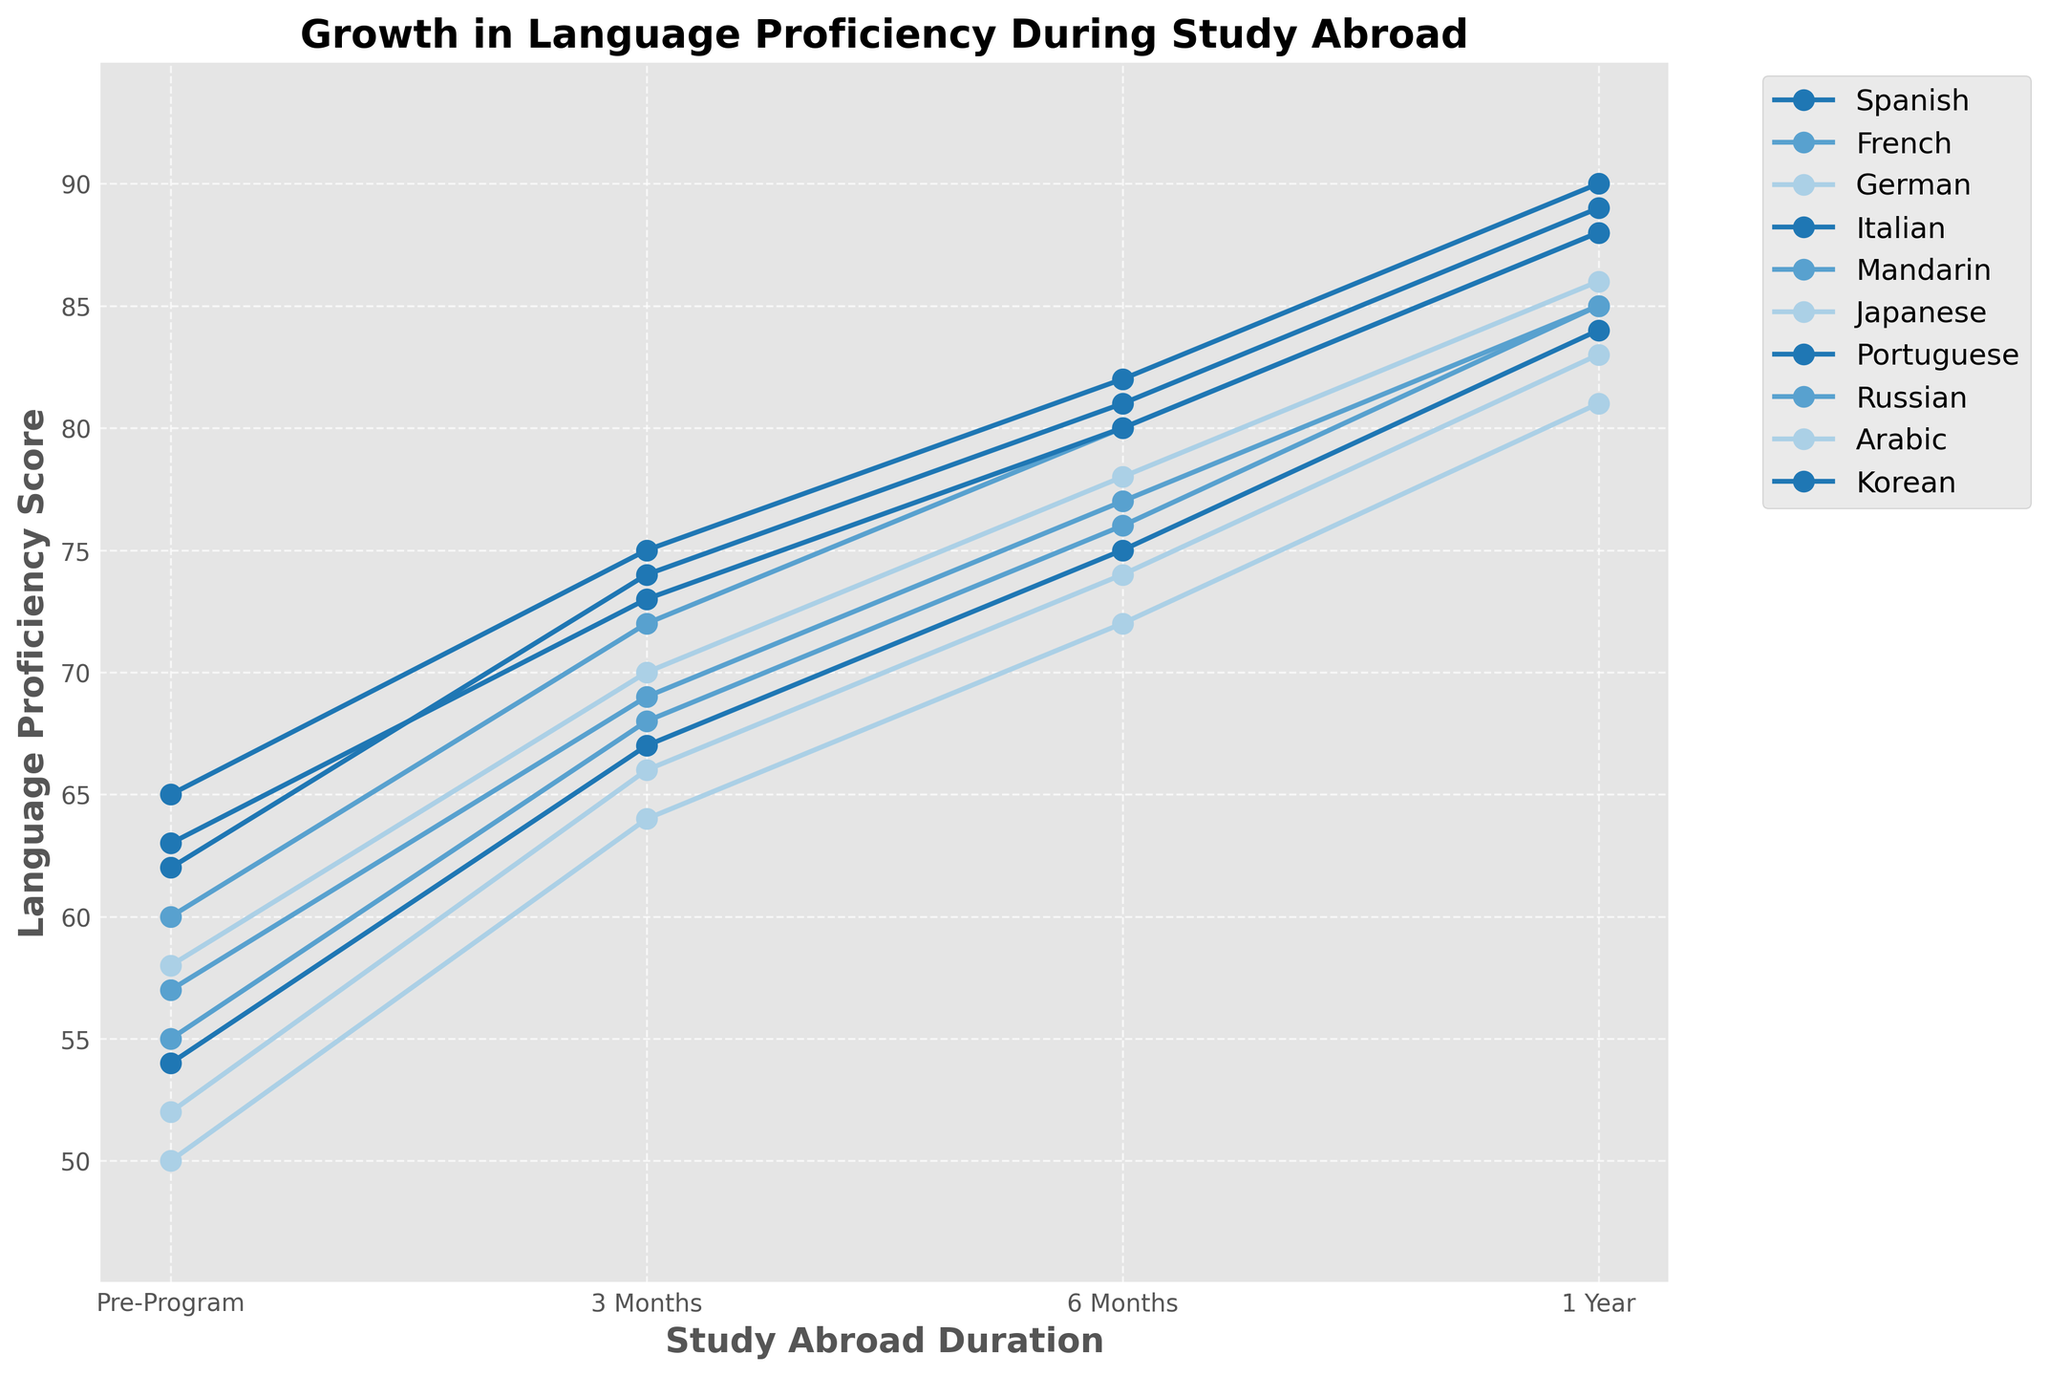What's the difference in language proficiency scores for Spanish between the Pre-Program period and 1 Year Abroad? To find the difference, subtract the Pre-Program score (65) from the 1 Year Abroad score (90): 90 - 65 = 25
Answer: 25 Which language shows the highest proficiency score after 1 Year Abroad? By comparing all the scores at the 1 Year Abroad mark, we find that Spanish has a score of 90, which is the highest among all languages listed.
Answer: Spanish What is the average proficiency score for French across all time periods shown? To find the average, sum up the French scores for all periods and divide by the number of periods: (60 + 72 + 80 + 88) / 4 = 75
Answer: 75 Between Japanese and Korean, which language shows a higher proficiency score at 6 Months Abroad? By comparing the scores at 6 Months Abroad, Japanese has a score of 74 while Korean has a score of 75. Therefore, Korean scores higher.
Answer: Korean What is the percentage increase in proficiency for Mandarin from Pre-Program to 1 Year Abroad? To calculate the percentage increase: [(85 - 55) / 55] * 100 = 54.55%
Answer: 54.55% Comparing German and Italian, which language has a greater improvement from Pre-Program to 3 Months Abroad? German's improvement: 70 - 58 = 12; Italian's improvement: 74 - 62 = 12. Both languages have the same amount of improvement.
Answer: Both By how many points does Arabic proficiency increase from Pre-Program to 6 Months Abroad? Subtract the Pre-Program score (50) from the 6 Months Abroad score (72): 72 - 50 = 22
Answer: 22 Which language shows the smallest improvement between the Pre-Program and 1 Year Abroad periods? Arabic shows the smallest improvement: 81 - 50 = 31. No other language has a smaller increase.
Answer: Arabic What is the total proficiency score for all languages at the 3 Months Abroad period? Sum all the scores at the 3 Months Abroad mark: 75 + 72 + 70 + 74 + 68 + 66 + 73 + 69 + 64 + 67 = 698
Answer: 698 